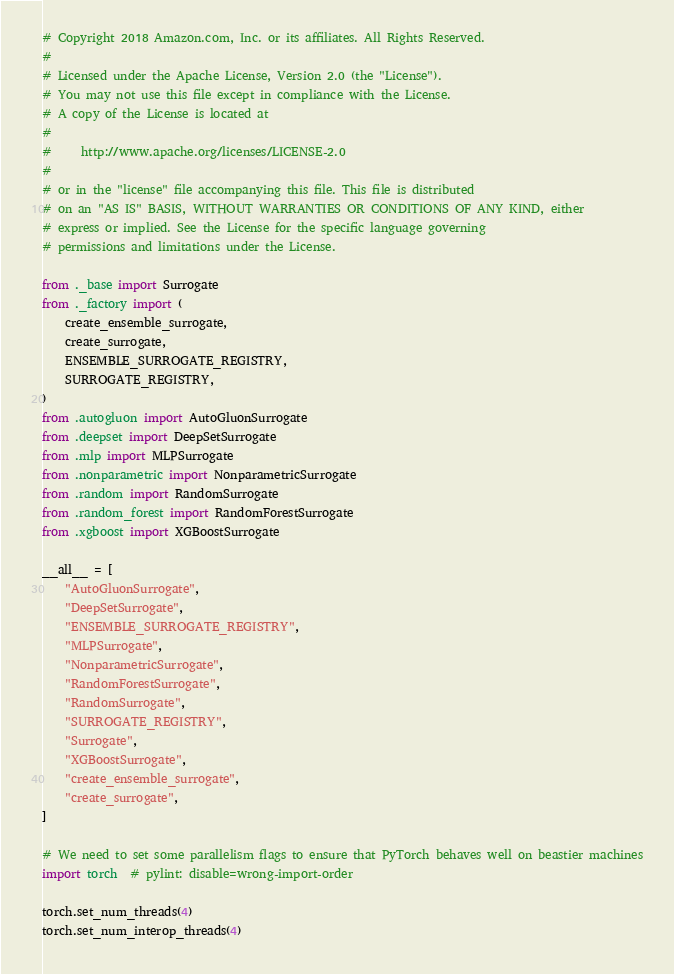<code> <loc_0><loc_0><loc_500><loc_500><_Python_># Copyright 2018 Amazon.com, Inc. or its affiliates. All Rights Reserved.
#
# Licensed under the Apache License, Version 2.0 (the "License").
# You may not use this file except in compliance with the License.
# A copy of the License is located at
#
#     http://www.apache.org/licenses/LICENSE-2.0
#
# or in the "license" file accompanying this file. This file is distributed
# on an "AS IS" BASIS, WITHOUT WARRANTIES OR CONDITIONS OF ANY KIND, either
# express or implied. See the License for the specific language governing
# permissions and limitations under the License.

from ._base import Surrogate
from ._factory import (
    create_ensemble_surrogate,
    create_surrogate,
    ENSEMBLE_SURROGATE_REGISTRY,
    SURROGATE_REGISTRY,
)
from .autogluon import AutoGluonSurrogate
from .deepset import DeepSetSurrogate
from .mlp import MLPSurrogate
from .nonparametric import NonparametricSurrogate
from .random import RandomSurrogate
from .random_forest import RandomForestSurrogate
from .xgboost import XGBoostSurrogate

__all__ = [
    "AutoGluonSurrogate",
    "DeepSetSurrogate",
    "ENSEMBLE_SURROGATE_REGISTRY",
    "MLPSurrogate",
    "NonparametricSurrogate",
    "RandomForestSurrogate",
    "RandomSurrogate",
    "SURROGATE_REGISTRY",
    "Surrogate",
    "XGBoostSurrogate",
    "create_ensemble_surrogate",
    "create_surrogate",
]

# We need to set some parallelism flags to ensure that PyTorch behaves well on beastier machines
import torch  # pylint: disable=wrong-import-order

torch.set_num_threads(4)
torch.set_num_interop_threads(4)
</code> 